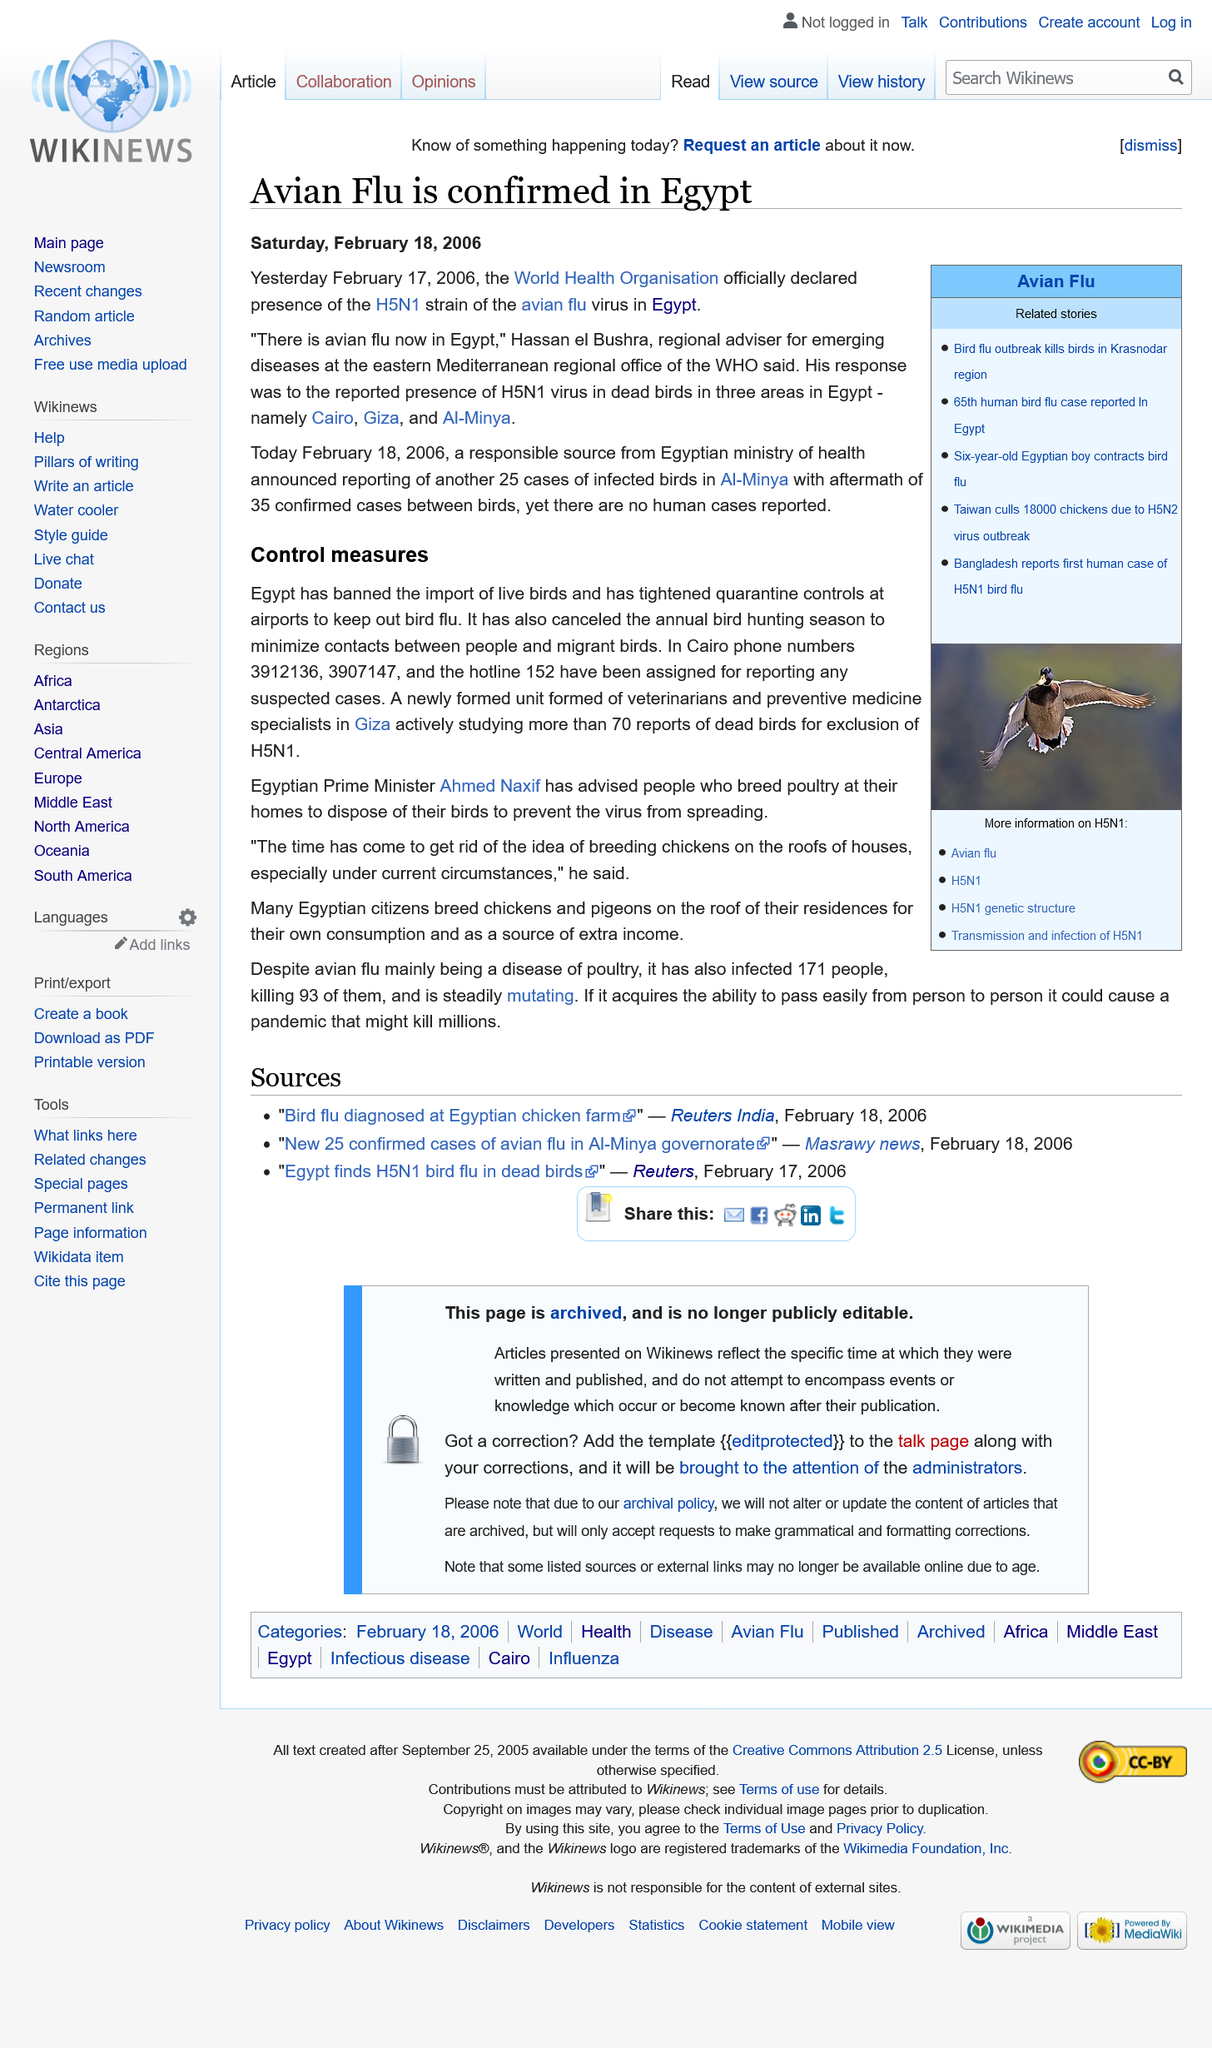Identify some key points in this picture. Ahmed Naxif is the current Egyptian Prime Minister. The respondent mentioned the detection of H5N1 virus in dead birds in three areas in Egypt: Cairo, Giza, and Al-Minya. The World Health Organization (WHO) officially declared the presence of the H5N1 strain of the avian flu virus in Egypt. On February 18, 2006, the Egyptian Ministry of Health announced an additional 25 cases of infected birds. Ahmed Naxif stated that "the time has come to get rid of the idea of breeding chickens on the roofs of houses. 